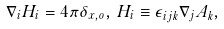<formula> <loc_0><loc_0><loc_500><loc_500>\nabla _ { i } H _ { i } = 4 \pi \delta _ { x , o } , \, H _ { i } \equiv \epsilon _ { i j k } \nabla _ { j } A _ { k } ,</formula> 